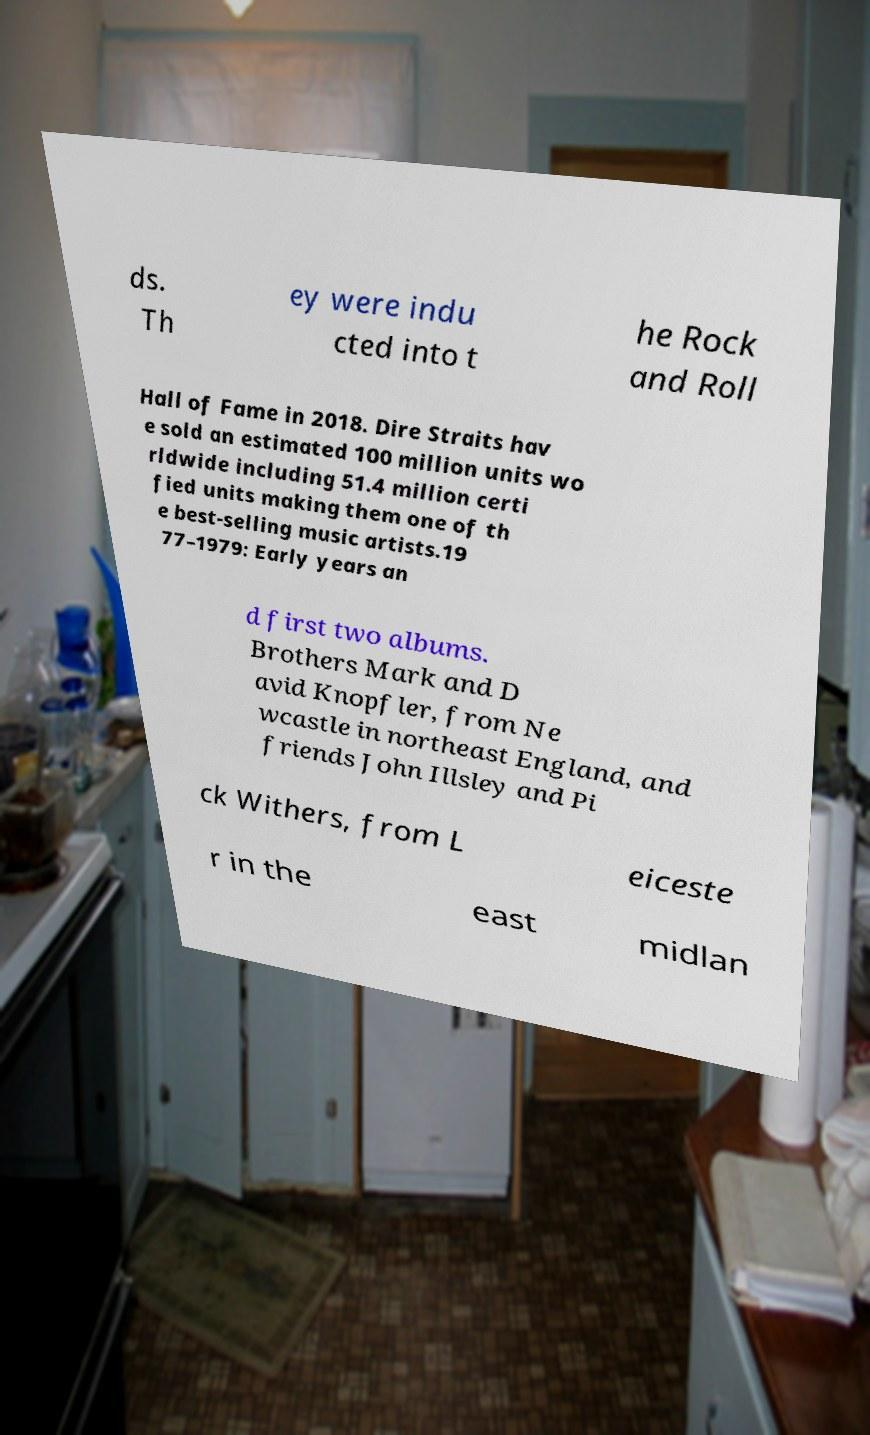For documentation purposes, I need the text within this image transcribed. Could you provide that? ds. Th ey were indu cted into t he Rock and Roll Hall of Fame in 2018. Dire Straits hav e sold an estimated 100 million units wo rldwide including 51.4 million certi fied units making them one of th e best-selling music artists.19 77–1979: Early years an d first two albums. Brothers Mark and D avid Knopfler, from Ne wcastle in northeast England, and friends John Illsley and Pi ck Withers, from L eiceste r in the east midlan 